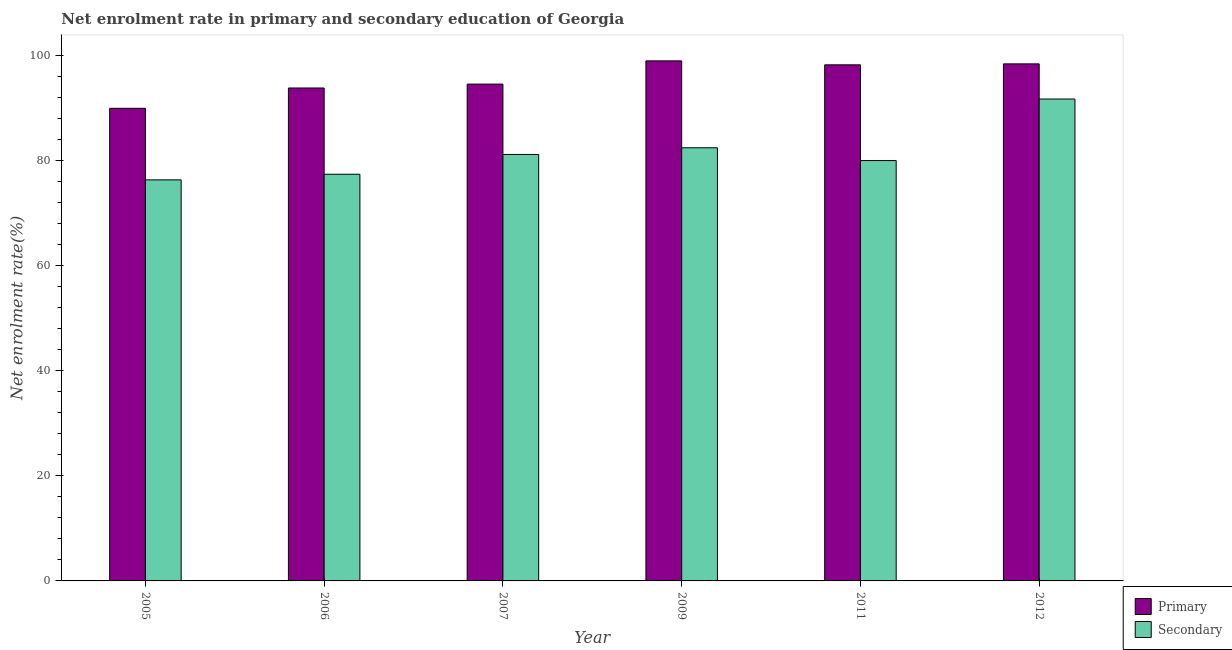How many different coloured bars are there?
Offer a very short reply. 2. How many bars are there on the 5th tick from the left?
Your response must be concise. 2. How many bars are there on the 6th tick from the right?
Provide a short and direct response. 2. What is the label of the 5th group of bars from the left?
Provide a short and direct response. 2011. What is the enrollment rate in primary education in 2005?
Keep it short and to the point. 89.89. Across all years, what is the maximum enrollment rate in secondary education?
Provide a short and direct response. 91.66. Across all years, what is the minimum enrollment rate in secondary education?
Keep it short and to the point. 76.28. In which year was the enrollment rate in primary education maximum?
Keep it short and to the point. 2009. In which year was the enrollment rate in primary education minimum?
Your answer should be compact. 2005. What is the total enrollment rate in primary education in the graph?
Your response must be concise. 573.57. What is the difference between the enrollment rate in primary education in 2007 and that in 2012?
Offer a terse response. -3.85. What is the difference between the enrollment rate in secondary education in 2005 and the enrollment rate in primary education in 2009?
Your response must be concise. -6.11. What is the average enrollment rate in secondary education per year?
Give a very brief answer. 81.46. What is the ratio of the enrollment rate in secondary education in 2006 to that in 2012?
Offer a terse response. 0.84. Is the enrollment rate in primary education in 2006 less than that in 2011?
Provide a short and direct response. Yes. Is the difference between the enrollment rate in secondary education in 2006 and 2012 greater than the difference between the enrollment rate in primary education in 2006 and 2012?
Provide a short and direct response. No. What is the difference between the highest and the second highest enrollment rate in secondary education?
Your answer should be very brief. 9.27. What is the difference between the highest and the lowest enrollment rate in secondary education?
Make the answer very short. 15.38. What does the 1st bar from the left in 2012 represents?
Ensure brevity in your answer.  Primary. What does the 2nd bar from the right in 2006 represents?
Provide a short and direct response. Primary. Are all the bars in the graph horizontal?
Provide a succinct answer. No. Are the values on the major ticks of Y-axis written in scientific E-notation?
Your response must be concise. No. Does the graph contain any zero values?
Your response must be concise. No. Does the graph contain grids?
Ensure brevity in your answer.  No. Where does the legend appear in the graph?
Your answer should be very brief. Bottom right. How many legend labels are there?
Give a very brief answer. 2. How are the legend labels stacked?
Make the answer very short. Vertical. What is the title of the graph?
Provide a short and direct response. Net enrolment rate in primary and secondary education of Georgia. What is the label or title of the X-axis?
Make the answer very short. Year. What is the label or title of the Y-axis?
Your answer should be very brief. Net enrolment rate(%). What is the Net enrolment rate(%) of Primary in 2005?
Keep it short and to the point. 89.89. What is the Net enrolment rate(%) of Secondary in 2005?
Your response must be concise. 76.28. What is the Net enrolment rate(%) of Primary in 2006?
Your response must be concise. 93.76. What is the Net enrolment rate(%) of Secondary in 2006?
Your response must be concise. 77.35. What is the Net enrolment rate(%) in Primary in 2007?
Make the answer very short. 94.5. What is the Net enrolment rate(%) of Secondary in 2007?
Your answer should be compact. 81.11. What is the Net enrolment rate(%) of Primary in 2009?
Your response must be concise. 98.92. What is the Net enrolment rate(%) in Secondary in 2009?
Your answer should be very brief. 82.39. What is the Net enrolment rate(%) in Primary in 2011?
Offer a very short reply. 98.16. What is the Net enrolment rate(%) of Secondary in 2011?
Offer a terse response. 79.96. What is the Net enrolment rate(%) in Primary in 2012?
Make the answer very short. 98.35. What is the Net enrolment rate(%) in Secondary in 2012?
Your answer should be compact. 91.66. Across all years, what is the maximum Net enrolment rate(%) of Primary?
Ensure brevity in your answer.  98.92. Across all years, what is the maximum Net enrolment rate(%) in Secondary?
Your answer should be very brief. 91.66. Across all years, what is the minimum Net enrolment rate(%) of Primary?
Offer a terse response. 89.89. Across all years, what is the minimum Net enrolment rate(%) of Secondary?
Offer a terse response. 76.28. What is the total Net enrolment rate(%) in Primary in the graph?
Offer a terse response. 573.57. What is the total Net enrolment rate(%) in Secondary in the graph?
Ensure brevity in your answer.  488.75. What is the difference between the Net enrolment rate(%) of Primary in 2005 and that in 2006?
Make the answer very short. -3.87. What is the difference between the Net enrolment rate(%) in Secondary in 2005 and that in 2006?
Your response must be concise. -1.07. What is the difference between the Net enrolment rate(%) in Primary in 2005 and that in 2007?
Offer a terse response. -4.61. What is the difference between the Net enrolment rate(%) in Secondary in 2005 and that in 2007?
Give a very brief answer. -4.83. What is the difference between the Net enrolment rate(%) of Primary in 2005 and that in 2009?
Keep it short and to the point. -9.02. What is the difference between the Net enrolment rate(%) in Secondary in 2005 and that in 2009?
Give a very brief answer. -6.11. What is the difference between the Net enrolment rate(%) in Primary in 2005 and that in 2011?
Your answer should be very brief. -8.27. What is the difference between the Net enrolment rate(%) in Secondary in 2005 and that in 2011?
Make the answer very short. -3.67. What is the difference between the Net enrolment rate(%) in Primary in 2005 and that in 2012?
Your answer should be very brief. -8.45. What is the difference between the Net enrolment rate(%) of Secondary in 2005 and that in 2012?
Your answer should be very brief. -15.38. What is the difference between the Net enrolment rate(%) in Primary in 2006 and that in 2007?
Give a very brief answer. -0.74. What is the difference between the Net enrolment rate(%) in Secondary in 2006 and that in 2007?
Keep it short and to the point. -3.76. What is the difference between the Net enrolment rate(%) of Primary in 2006 and that in 2009?
Make the answer very short. -5.16. What is the difference between the Net enrolment rate(%) of Secondary in 2006 and that in 2009?
Your answer should be very brief. -5.04. What is the difference between the Net enrolment rate(%) in Primary in 2006 and that in 2011?
Your response must be concise. -4.4. What is the difference between the Net enrolment rate(%) in Secondary in 2006 and that in 2011?
Provide a succinct answer. -2.6. What is the difference between the Net enrolment rate(%) of Primary in 2006 and that in 2012?
Offer a very short reply. -4.59. What is the difference between the Net enrolment rate(%) of Secondary in 2006 and that in 2012?
Keep it short and to the point. -14.31. What is the difference between the Net enrolment rate(%) in Primary in 2007 and that in 2009?
Ensure brevity in your answer.  -4.42. What is the difference between the Net enrolment rate(%) of Secondary in 2007 and that in 2009?
Provide a succinct answer. -1.27. What is the difference between the Net enrolment rate(%) in Primary in 2007 and that in 2011?
Make the answer very short. -3.66. What is the difference between the Net enrolment rate(%) in Secondary in 2007 and that in 2011?
Offer a terse response. 1.16. What is the difference between the Net enrolment rate(%) in Primary in 2007 and that in 2012?
Your answer should be very brief. -3.85. What is the difference between the Net enrolment rate(%) of Secondary in 2007 and that in 2012?
Ensure brevity in your answer.  -10.54. What is the difference between the Net enrolment rate(%) of Primary in 2009 and that in 2011?
Offer a very short reply. 0.75. What is the difference between the Net enrolment rate(%) of Secondary in 2009 and that in 2011?
Offer a very short reply. 2.43. What is the difference between the Net enrolment rate(%) of Primary in 2009 and that in 2012?
Keep it short and to the point. 0.57. What is the difference between the Net enrolment rate(%) of Secondary in 2009 and that in 2012?
Offer a terse response. -9.27. What is the difference between the Net enrolment rate(%) in Primary in 2011 and that in 2012?
Offer a terse response. -0.18. What is the difference between the Net enrolment rate(%) of Secondary in 2011 and that in 2012?
Give a very brief answer. -11.7. What is the difference between the Net enrolment rate(%) of Primary in 2005 and the Net enrolment rate(%) of Secondary in 2006?
Offer a very short reply. 12.54. What is the difference between the Net enrolment rate(%) in Primary in 2005 and the Net enrolment rate(%) in Secondary in 2007?
Keep it short and to the point. 8.78. What is the difference between the Net enrolment rate(%) in Primary in 2005 and the Net enrolment rate(%) in Secondary in 2009?
Provide a short and direct response. 7.5. What is the difference between the Net enrolment rate(%) of Primary in 2005 and the Net enrolment rate(%) of Secondary in 2011?
Provide a short and direct response. 9.94. What is the difference between the Net enrolment rate(%) in Primary in 2005 and the Net enrolment rate(%) in Secondary in 2012?
Ensure brevity in your answer.  -1.77. What is the difference between the Net enrolment rate(%) in Primary in 2006 and the Net enrolment rate(%) in Secondary in 2007?
Offer a terse response. 12.64. What is the difference between the Net enrolment rate(%) of Primary in 2006 and the Net enrolment rate(%) of Secondary in 2009?
Keep it short and to the point. 11.37. What is the difference between the Net enrolment rate(%) of Primary in 2006 and the Net enrolment rate(%) of Secondary in 2011?
Provide a short and direct response. 13.8. What is the difference between the Net enrolment rate(%) of Primary in 2006 and the Net enrolment rate(%) of Secondary in 2012?
Keep it short and to the point. 2.1. What is the difference between the Net enrolment rate(%) in Primary in 2007 and the Net enrolment rate(%) in Secondary in 2009?
Give a very brief answer. 12.11. What is the difference between the Net enrolment rate(%) in Primary in 2007 and the Net enrolment rate(%) in Secondary in 2011?
Make the answer very short. 14.54. What is the difference between the Net enrolment rate(%) of Primary in 2007 and the Net enrolment rate(%) of Secondary in 2012?
Offer a terse response. 2.84. What is the difference between the Net enrolment rate(%) of Primary in 2009 and the Net enrolment rate(%) of Secondary in 2011?
Keep it short and to the point. 18.96. What is the difference between the Net enrolment rate(%) in Primary in 2009 and the Net enrolment rate(%) in Secondary in 2012?
Offer a very short reply. 7.26. What is the difference between the Net enrolment rate(%) of Primary in 2011 and the Net enrolment rate(%) of Secondary in 2012?
Your response must be concise. 6.5. What is the average Net enrolment rate(%) of Primary per year?
Provide a short and direct response. 95.6. What is the average Net enrolment rate(%) in Secondary per year?
Provide a short and direct response. 81.46. In the year 2005, what is the difference between the Net enrolment rate(%) of Primary and Net enrolment rate(%) of Secondary?
Your answer should be compact. 13.61. In the year 2006, what is the difference between the Net enrolment rate(%) in Primary and Net enrolment rate(%) in Secondary?
Make the answer very short. 16.41. In the year 2007, what is the difference between the Net enrolment rate(%) of Primary and Net enrolment rate(%) of Secondary?
Your answer should be very brief. 13.38. In the year 2009, what is the difference between the Net enrolment rate(%) in Primary and Net enrolment rate(%) in Secondary?
Your answer should be compact. 16.53. In the year 2011, what is the difference between the Net enrolment rate(%) in Primary and Net enrolment rate(%) in Secondary?
Ensure brevity in your answer.  18.21. In the year 2012, what is the difference between the Net enrolment rate(%) in Primary and Net enrolment rate(%) in Secondary?
Your answer should be compact. 6.69. What is the ratio of the Net enrolment rate(%) of Primary in 2005 to that in 2006?
Give a very brief answer. 0.96. What is the ratio of the Net enrolment rate(%) of Secondary in 2005 to that in 2006?
Your answer should be very brief. 0.99. What is the ratio of the Net enrolment rate(%) in Primary in 2005 to that in 2007?
Make the answer very short. 0.95. What is the ratio of the Net enrolment rate(%) in Secondary in 2005 to that in 2007?
Ensure brevity in your answer.  0.94. What is the ratio of the Net enrolment rate(%) in Primary in 2005 to that in 2009?
Offer a terse response. 0.91. What is the ratio of the Net enrolment rate(%) in Secondary in 2005 to that in 2009?
Your answer should be compact. 0.93. What is the ratio of the Net enrolment rate(%) of Primary in 2005 to that in 2011?
Keep it short and to the point. 0.92. What is the ratio of the Net enrolment rate(%) in Secondary in 2005 to that in 2011?
Keep it short and to the point. 0.95. What is the ratio of the Net enrolment rate(%) of Primary in 2005 to that in 2012?
Give a very brief answer. 0.91. What is the ratio of the Net enrolment rate(%) in Secondary in 2005 to that in 2012?
Offer a very short reply. 0.83. What is the ratio of the Net enrolment rate(%) in Primary in 2006 to that in 2007?
Provide a succinct answer. 0.99. What is the ratio of the Net enrolment rate(%) in Secondary in 2006 to that in 2007?
Ensure brevity in your answer.  0.95. What is the ratio of the Net enrolment rate(%) in Primary in 2006 to that in 2009?
Provide a short and direct response. 0.95. What is the ratio of the Net enrolment rate(%) of Secondary in 2006 to that in 2009?
Keep it short and to the point. 0.94. What is the ratio of the Net enrolment rate(%) in Primary in 2006 to that in 2011?
Keep it short and to the point. 0.96. What is the ratio of the Net enrolment rate(%) in Secondary in 2006 to that in 2011?
Offer a very short reply. 0.97. What is the ratio of the Net enrolment rate(%) of Primary in 2006 to that in 2012?
Offer a terse response. 0.95. What is the ratio of the Net enrolment rate(%) in Secondary in 2006 to that in 2012?
Give a very brief answer. 0.84. What is the ratio of the Net enrolment rate(%) in Primary in 2007 to that in 2009?
Ensure brevity in your answer.  0.96. What is the ratio of the Net enrolment rate(%) of Secondary in 2007 to that in 2009?
Your response must be concise. 0.98. What is the ratio of the Net enrolment rate(%) of Primary in 2007 to that in 2011?
Keep it short and to the point. 0.96. What is the ratio of the Net enrolment rate(%) of Secondary in 2007 to that in 2011?
Your answer should be compact. 1.01. What is the ratio of the Net enrolment rate(%) in Primary in 2007 to that in 2012?
Offer a very short reply. 0.96. What is the ratio of the Net enrolment rate(%) of Secondary in 2007 to that in 2012?
Make the answer very short. 0.89. What is the ratio of the Net enrolment rate(%) in Primary in 2009 to that in 2011?
Your answer should be compact. 1.01. What is the ratio of the Net enrolment rate(%) of Secondary in 2009 to that in 2011?
Provide a short and direct response. 1.03. What is the ratio of the Net enrolment rate(%) in Secondary in 2009 to that in 2012?
Your response must be concise. 0.9. What is the ratio of the Net enrolment rate(%) of Secondary in 2011 to that in 2012?
Give a very brief answer. 0.87. What is the difference between the highest and the second highest Net enrolment rate(%) of Primary?
Your answer should be very brief. 0.57. What is the difference between the highest and the second highest Net enrolment rate(%) in Secondary?
Your answer should be compact. 9.27. What is the difference between the highest and the lowest Net enrolment rate(%) in Primary?
Offer a very short reply. 9.02. What is the difference between the highest and the lowest Net enrolment rate(%) in Secondary?
Give a very brief answer. 15.38. 